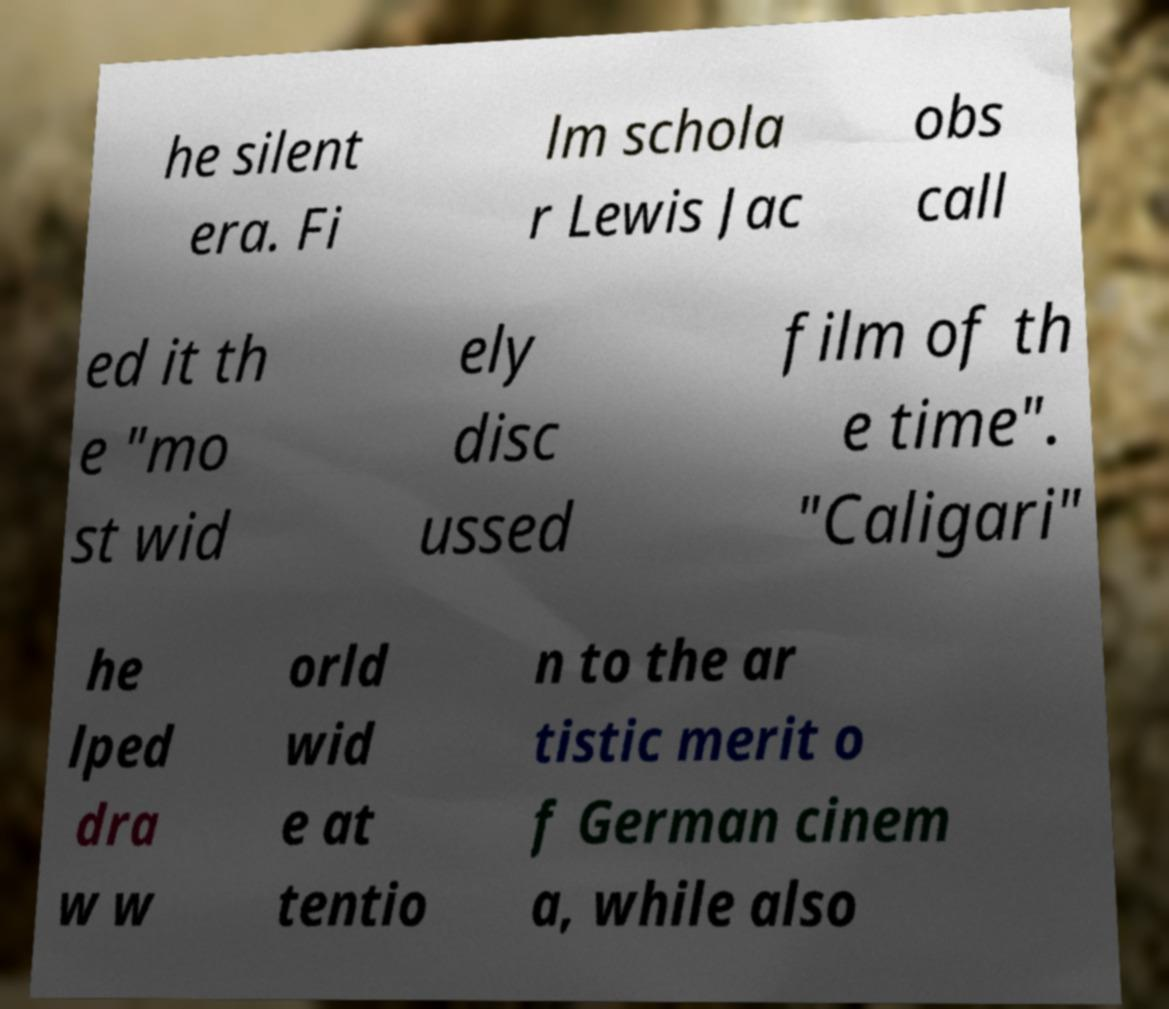What messages or text are displayed in this image? I need them in a readable, typed format. he silent era. Fi lm schola r Lewis Jac obs call ed it th e "mo st wid ely disc ussed film of th e time". "Caligari" he lped dra w w orld wid e at tentio n to the ar tistic merit o f German cinem a, while also 